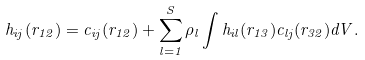<formula> <loc_0><loc_0><loc_500><loc_500>h _ { i j } ( r _ { 1 2 } ) = c _ { i j } ( r _ { 1 2 } ) + \sum _ { l = 1 } ^ { S } \rho _ { l } \int h _ { i l } ( r _ { 1 3 } ) c _ { l j } ( r _ { 3 2 } ) d V .</formula> 